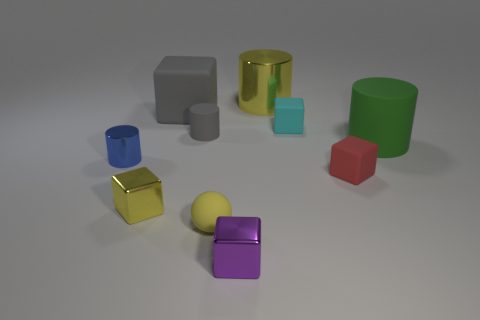What material is the large cylinder behind the small cube behind the blue cylinder? The large cylinder located behind the small cube, which is in turn behind the blue cylinder, appears to be made of a glossy metal, reflecting the environment with a smooth and shiny surface characteristic of metallic materials. 